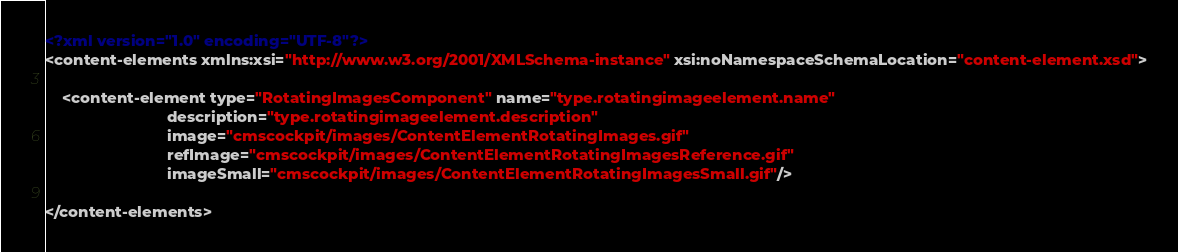Convert code to text. <code><loc_0><loc_0><loc_500><loc_500><_XML_><?xml version="1.0" encoding="UTF-8"?>
<content-elements xmlns:xsi="http://www.w3.org/2001/XMLSchema-instance" xsi:noNamespaceSchemaLocation="content-element.xsd">

	<content-element type="RotatingImagesComponent" name="type.rotatingimageelement.name"
							description="type.rotatingimageelement.description"
							image="cmscockpit/images/ContentElementRotatingImages.gif"
							refImage="cmscockpit/images/ContentElementRotatingImagesReference.gif"
							imageSmall="cmscockpit/images/ContentElementRotatingImagesSmall.gif"/>

</content-elements></code> 